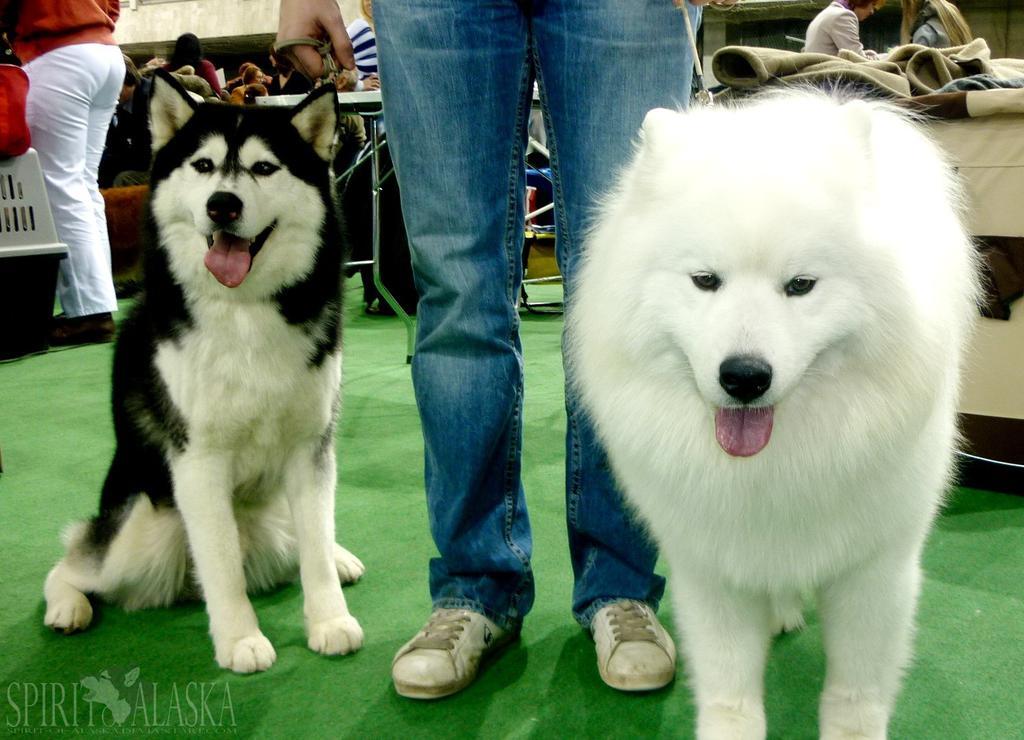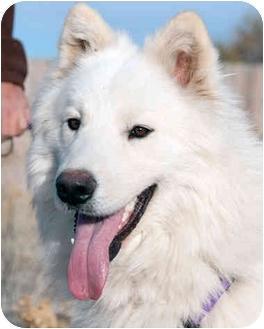The first image is the image on the left, the second image is the image on the right. Analyze the images presented: Is the assertion "One of the images shows exactly two dogs." valid? Answer yes or no. Yes. 